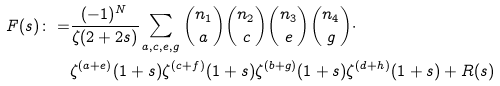<formula> <loc_0><loc_0><loc_500><loc_500>F ( s ) \colon = & \frac { ( - 1 ) ^ { N } } { \zeta ( 2 + 2 s ) } \sum _ { a , c , e , g } \binom { n _ { 1 } } { a } \binom { n _ { 2 } } { c } \binom { n _ { 3 } } { e } \binom { n _ { 4 } } { g } \cdot \\ & \zeta ^ { ( a + e ) } ( 1 + s ) \zeta ^ { ( c + f ) } ( 1 + s ) \zeta ^ { ( b + g ) } ( 1 + s ) \zeta ^ { ( d + h ) } ( 1 + s ) + R ( s ) \\</formula> 